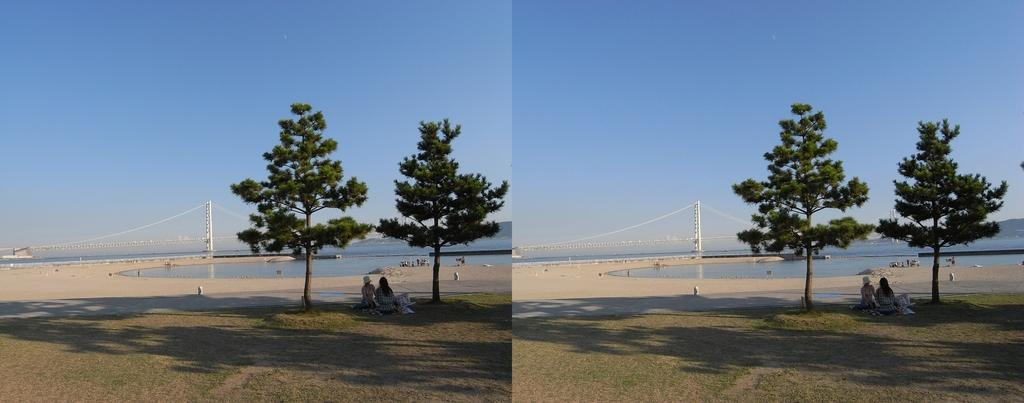What type of artwork is the image? The image is a collage. What are the two persons in the image doing? The two persons are sitting on the grass. What type of vegetation can be seen in the image? There are trees in the image. What natural element is visible in the image? There is water visible in the image. What structure can be seen in the image? There is a pole in the image. What is visible in the background of the image? The sky is visible in the background of the image. How does the person in the image kick the brake while sitting on the grass? There is no person kicking a brake in the image; the two persons are sitting on the grass, and there is no brake present. What type of heat source can be seen in the image? There is no heat source visible in the image. 